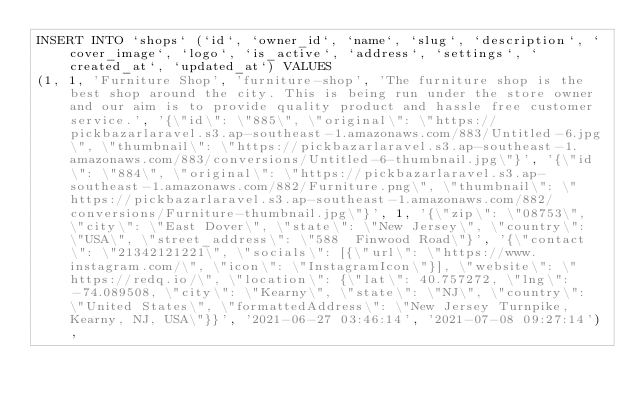Convert code to text. <code><loc_0><loc_0><loc_500><loc_500><_SQL_>INSERT INTO `shops` (`id`, `owner_id`, `name`, `slug`, `description`, `cover_image`, `logo`, `is_active`, `address`, `settings`, `created_at`, `updated_at`) VALUES
(1, 1, 'Furniture Shop', 'furniture-shop', 'The furniture shop is the best shop around the city. This is being run under the store owner and our aim is to provide quality product and hassle free customer service.', '{\"id\": \"885\", \"original\": \"https://pickbazarlaravel.s3.ap-southeast-1.amazonaws.com/883/Untitled-6.jpg\", \"thumbnail\": \"https://pickbazarlaravel.s3.ap-southeast-1.amazonaws.com/883/conversions/Untitled-6-thumbnail.jpg\"}', '{\"id\": \"884\", \"original\": \"https://pickbazarlaravel.s3.ap-southeast-1.amazonaws.com/882/Furniture.png\", \"thumbnail\": \"https://pickbazarlaravel.s3.ap-southeast-1.amazonaws.com/882/conversions/Furniture-thumbnail.jpg\"}', 1, '{\"zip\": \"08753\", \"city\": \"East Dover\", \"state\": \"New Jersey\", \"country\": \"USA\", \"street_address\": \"588  Finwood Road\"}', '{\"contact\": \"21342121221\", \"socials\": [{\"url\": \"https://www.instagram.com/\", \"icon\": \"InstagramIcon\"}], \"website\": \"https://redq.io/\", \"location\": {\"lat\": 40.757272, \"lng\": -74.089508, \"city\": \"Kearny\", \"state\": \"NJ\", \"country\": \"United States\", \"formattedAddress\": \"New Jersey Turnpike, Kearny, NJ, USA\"}}', '2021-06-27 03:46:14', '2021-07-08 09:27:14'),</code> 